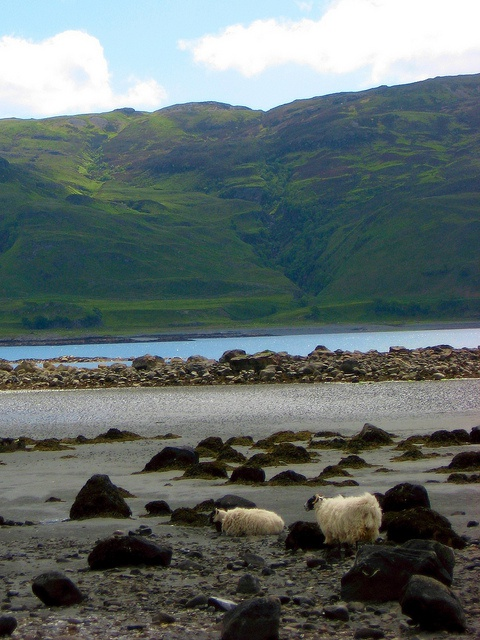Describe the objects in this image and their specific colors. I can see sheep in lightblue, gray, and black tones and sheep in lightblue, gray, black, and tan tones in this image. 